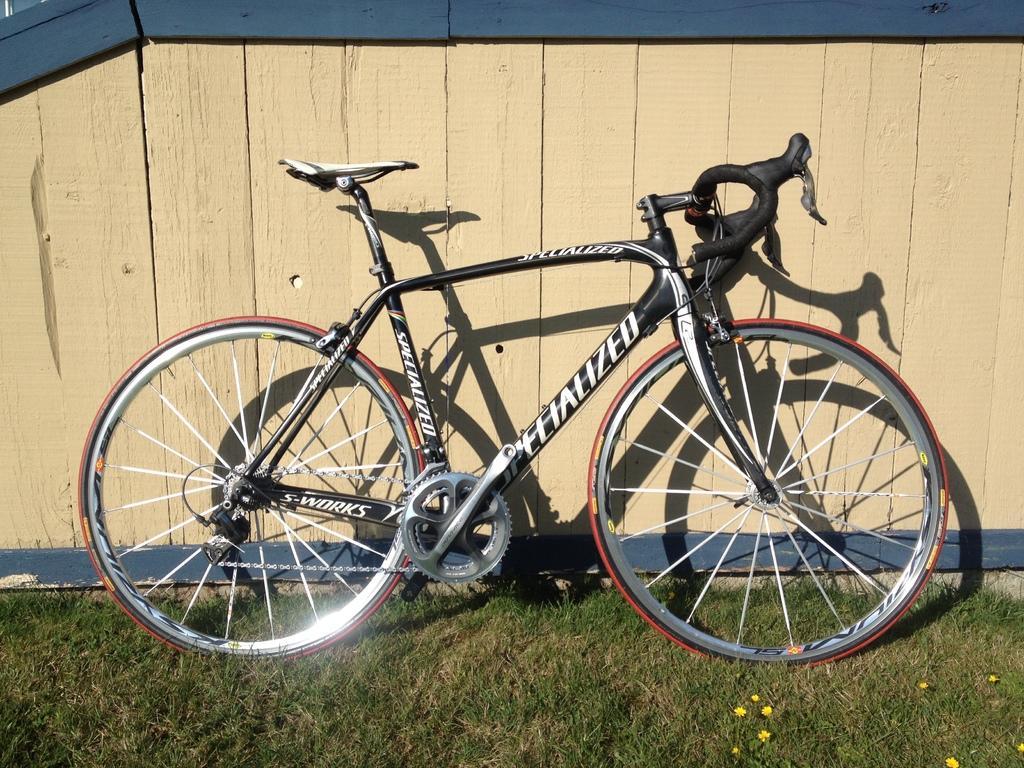How would you summarize this image in a sentence or two? In this image I can see some grass on the ground, few flowers which are yellow in color and a bicycle which is white, black and orange in color. I can see the wooden wall which is cream and blue in color. 